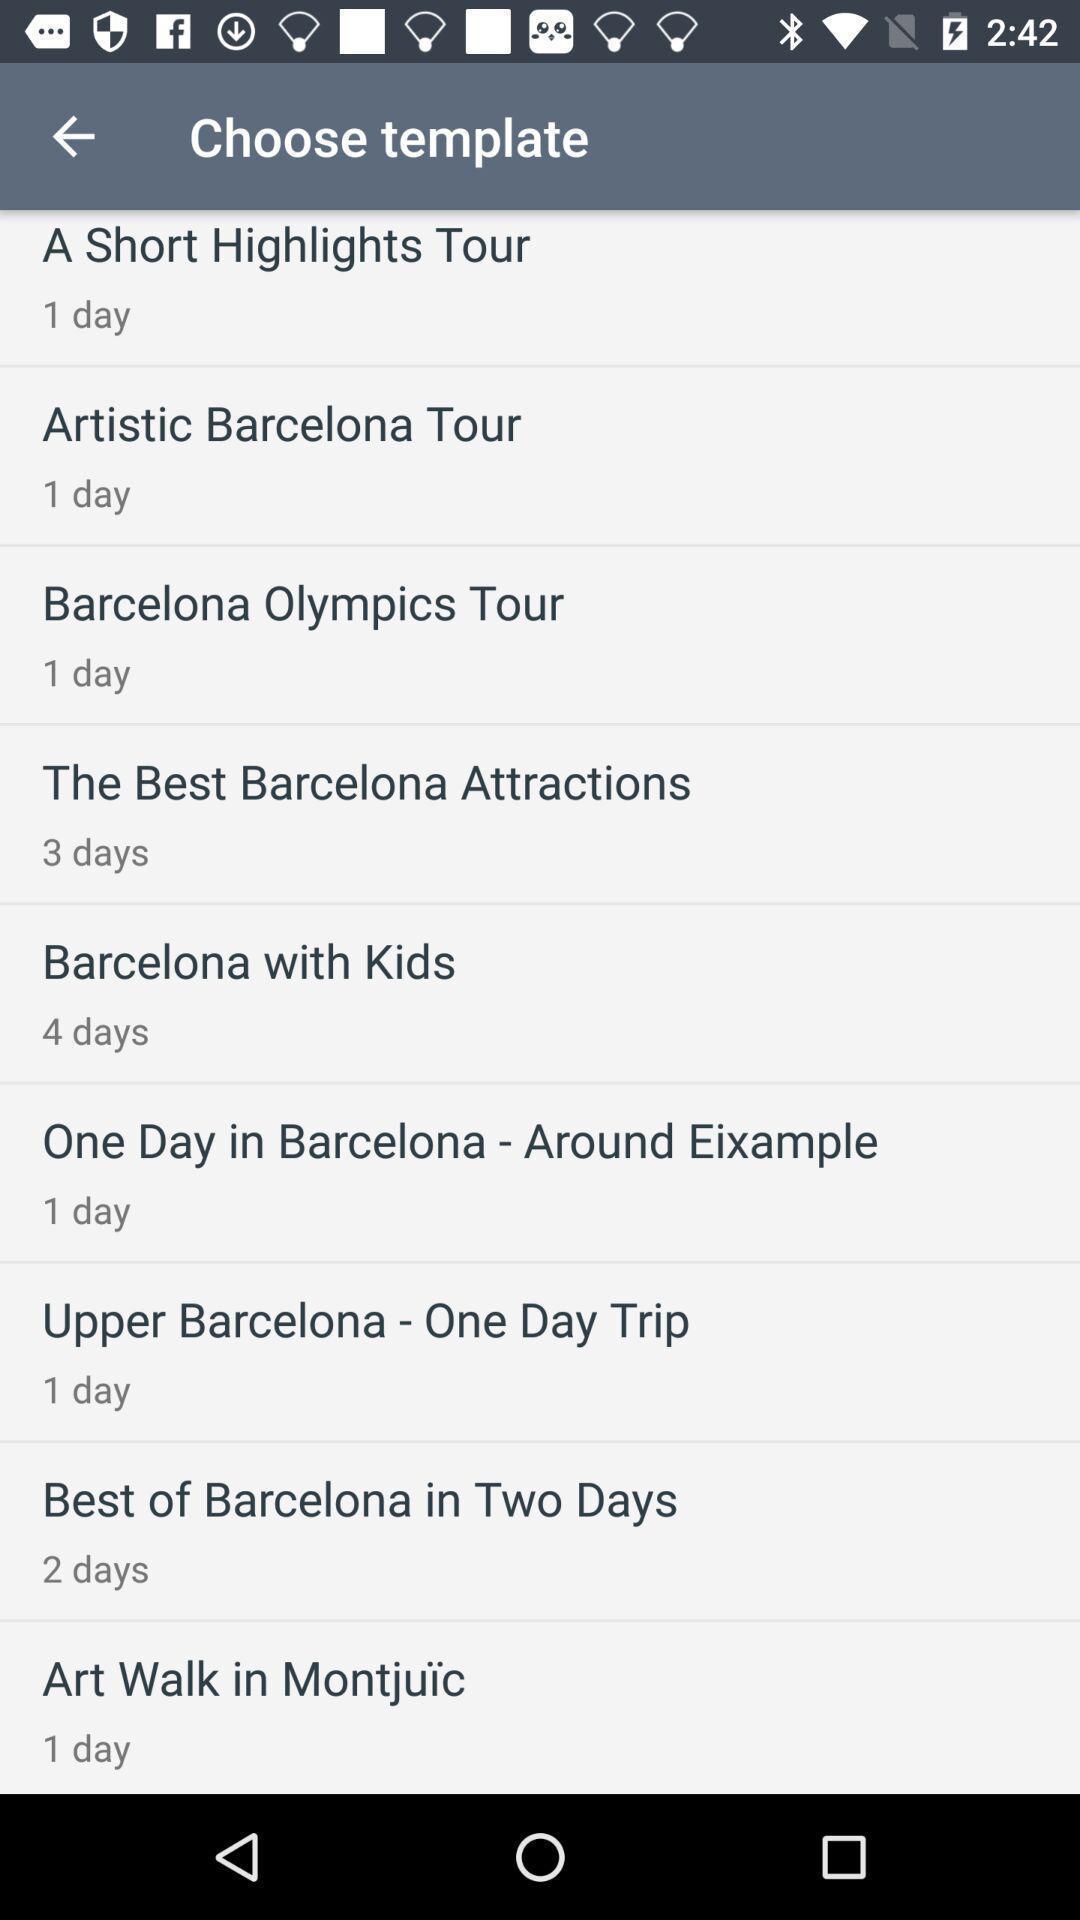What is the overall content of this screenshot? Page displaying various tour details with number of days. 